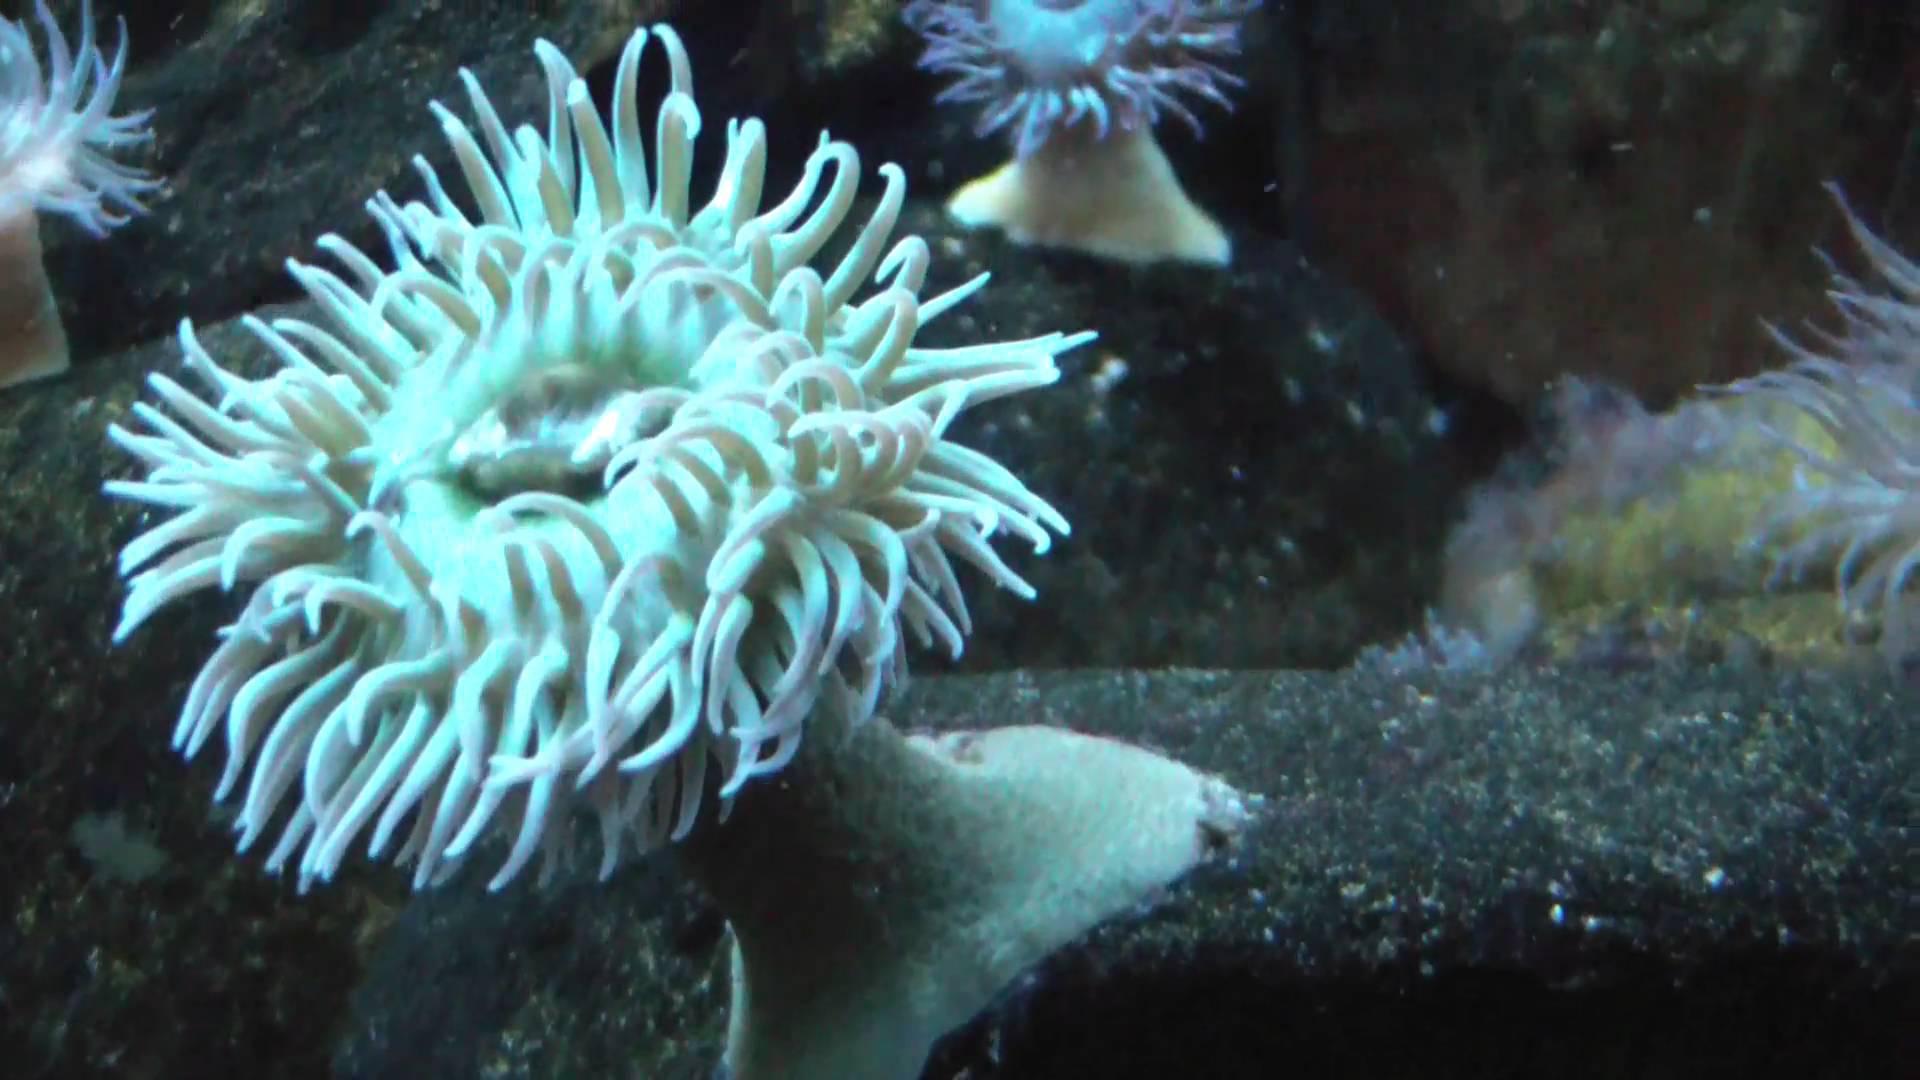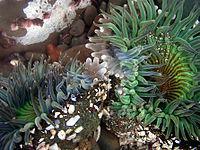The first image is the image on the left, the second image is the image on the right. For the images displayed, is the sentence "The trunk of the anemone can be seen in one of the images." factually correct? Answer yes or no. Yes. 